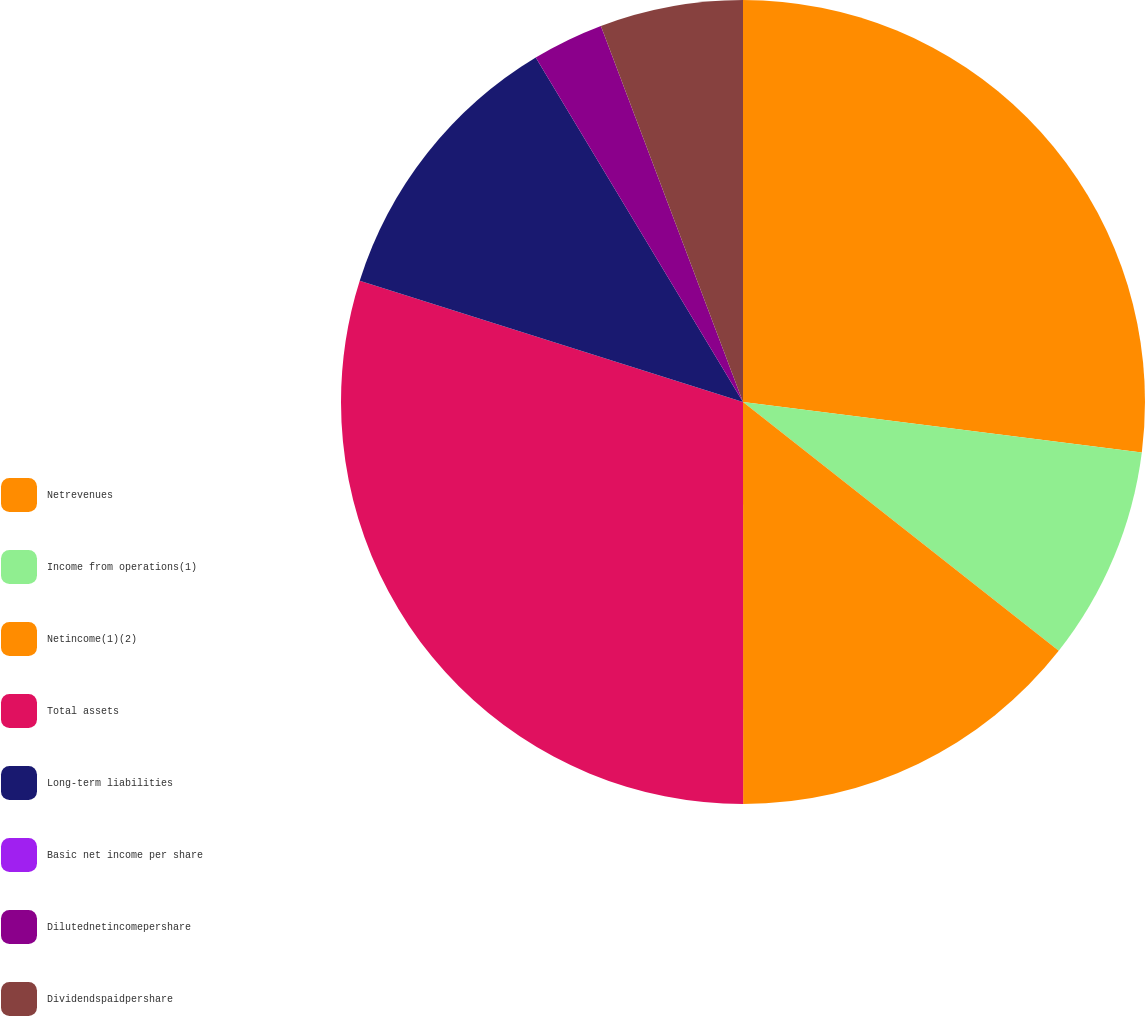Convert chart. <chart><loc_0><loc_0><loc_500><loc_500><pie_chart><fcel>Netrevenues<fcel>Income from operations(1)<fcel>Netincome(1)(2)<fcel>Total assets<fcel>Long-term liabilities<fcel>Basic net income per share<fcel>Dilutednetincomepershare<fcel>Dividendspaidpershare<nl><fcel>27.0%<fcel>8.62%<fcel>14.37%<fcel>29.88%<fcel>11.5%<fcel>0.0%<fcel>2.87%<fcel>5.75%<nl></chart> 